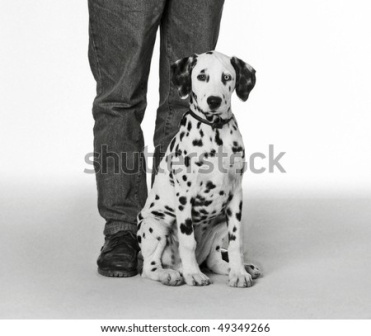What might the Dalmatian puppy be looking at? The Dalmatian puppy could be looking at various things. It could be gazing fondly at the person next to it, seeking attention or waiting for a treat. Alternatively, the puppy might be looking at a toy or something else intriguing in the distance. The upward focus of its gaze implies interest and curiosity, common traits in young puppies exploring their environment. Describe an imaginative scenario involving the puppy and its owner. In an enchanted forest, the Dalmatian puppy, named Spots, and its owner, Alex, embarked on an extraordinary adventure. Guided by an ancient map found in Alex’s attic, they set out to uncover the hidden treasures of the Whispering Woods. The map led them through magical groves where trees whispered secrets and rivers flowed with liquid light. As night fell, they stumbled upon a glowing clearing where a mystical crystal lay dormant. Spots, with his keen senses and unwavering loyalty, sensed the crystal’s significance. Together, they unlocked its power, which illuminated the forest and revealed a hidden pathway. This pathway, known only to those pure of heart, granted them entry to a realm where dreams intertwined with reality, and every step brought new wonders. 